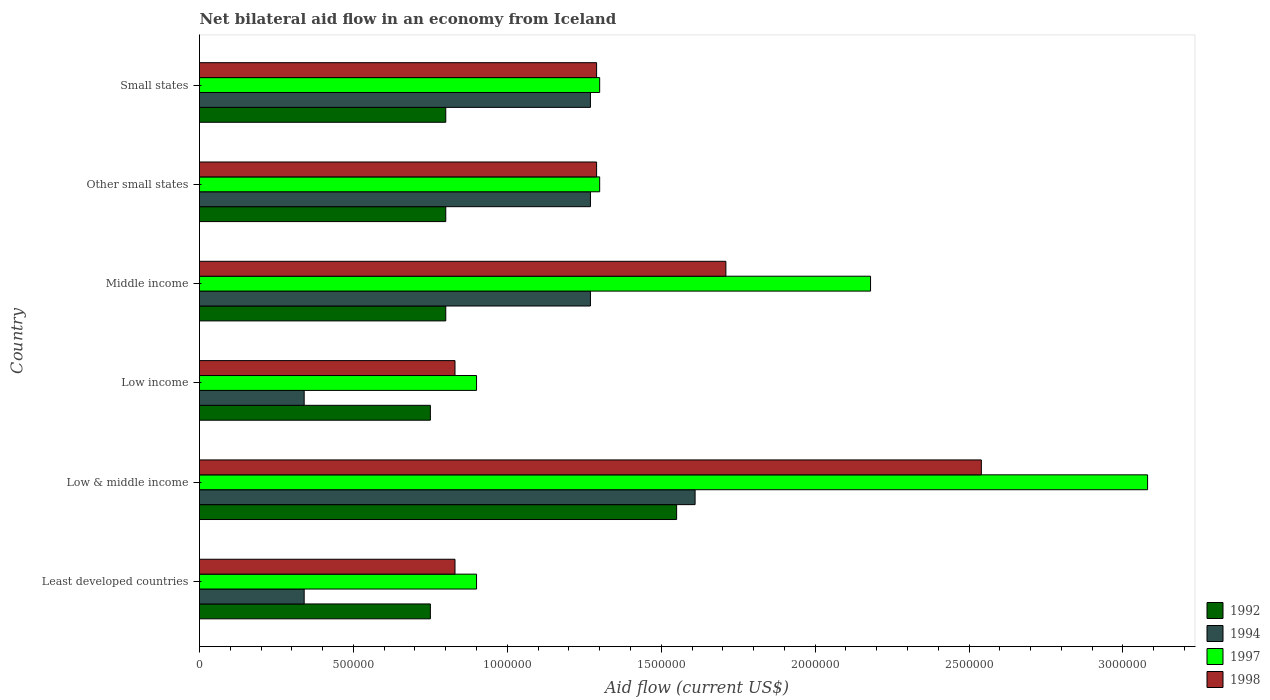Are the number of bars on each tick of the Y-axis equal?
Provide a succinct answer. Yes. Across all countries, what is the maximum net bilateral aid flow in 1992?
Provide a succinct answer. 1.55e+06. Across all countries, what is the minimum net bilateral aid flow in 1992?
Provide a short and direct response. 7.50e+05. In which country was the net bilateral aid flow in 1997 maximum?
Provide a short and direct response. Low & middle income. In which country was the net bilateral aid flow in 1997 minimum?
Keep it short and to the point. Least developed countries. What is the total net bilateral aid flow in 1994 in the graph?
Ensure brevity in your answer.  6.10e+06. What is the difference between the net bilateral aid flow in 1997 in Low & middle income and that in Middle income?
Provide a short and direct response. 9.00e+05. What is the difference between the net bilateral aid flow in 1997 in Middle income and the net bilateral aid flow in 1998 in Low income?
Offer a terse response. 1.35e+06. What is the average net bilateral aid flow in 1997 per country?
Ensure brevity in your answer.  1.61e+06. What is the difference between the net bilateral aid flow in 1997 and net bilateral aid flow in 1998 in Other small states?
Your answer should be compact. 10000. In how many countries, is the net bilateral aid flow in 1998 greater than 1200000 US$?
Your answer should be very brief. 4. What is the ratio of the net bilateral aid flow in 1992 in Low & middle income to that in Other small states?
Keep it short and to the point. 1.94. Is the net bilateral aid flow in 1998 in Low income less than that in Middle income?
Ensure brevity in your answer.  Yes. What is the difference between the highest and the second highest net bilateral aid flow in 1994?
Keep it short and to the point. 3.40e+05. What is the difference between the highest and the lowest net bilateral aid flow in 1992?
Your answer should be very brief. 8.00e+05. Is the sum of the net bilateral aid flow in 1994 in Low & middle income and Low income greater than the maximum net bilateral aid flow in 1992 across all countries?
Offer a very short reply. Yes. What does the 3rd bar from the top in Low & middle income represents?
Make the answer very short. 1994. What does the 4th bar from the bottom in Low income represents?
Provide a succinct answer. 1998. Is it the case that in every country, the sum of the net bilateral aid flow in 1994 and net bilateral aid flow in 1997 is greater than the net bilateral aid flow in 1998?
Your answer should be compact. Yes. How many bars are there?
Provide a short and direct response. 24. What is the difference between two consecutive major ticks on the X-axis?
Provide a short and direct response. 5.00e+05. Does the graph contain any zero values?
Your answer should be compact. No. How many legend labels are there?
Offer a very short reply. 4. How are the legend labels stacked?
Your answer should be very brief. Vertical. What is the title of the graph?
Your answer should be very brief. Net bilateral aid flow in an economy from Iceland. What is the label or title of the X-axis?
Make the answer very short. Aid flow (current US$). What is the Aid flow (current US$) in 1992 in Least developed countries?
Give a very brief answer. 7.50e+05. What is the Aid flow (current US$) of 1998 in Least developed countries?
Make the answer very short. 8.30e+05. What is the Aid flow (current US$) in 1992 in Low & middle income?
Offer a terse response. 1.55e+06. What is the Aid flow (current US$) of 1994 in Low & middle income?
Make the answer very short. 1.61e+06. What is the Aid flow (current US$) in 1997 in Low & middle income?
Your response must be concise. 3.08e+06. What is the Aid flow (current US$) of 1998 in Low & middle income?
Offer a very short reply. 2.54e+06. What is the Aid flow (current US$) of 1992 in Low income?
Keep it short and to the point. 7.50e+05. What is the Aid flow (current US$) of 1994 in Low income?
Make the answer very short. 3.40e+05. What is the Aid flow (current US$) in 1997 in Low income?
Offer a terse response. 9.00e+05. What is the Aid flow (current US$) in 1998 in Low income?
Keep it short and to the point. 8.30e+05. What is the Aid flow (current US$) of 1994 in Middle income?
Your answer should be very brief. 1.27e+06. What is the Aid flow (current US$) in 1997 in Middle income?
Make the answer very short. 2.18e+06. What is the Aid flow (current US$) of 1998 in Middle income?
Provide a short and direct response. 1.71e+06. What is the Aid flow (current US$) of 1992 in Other small states?
Provide a short and direct response. 8.00e+05. What is the Aid flow (current US$) in 1994 in Other small states?
Give a very brief answer. 1.27e+06. What is the Aid flow (current US$) in 1997 in Other small states?
Give a very brief answer. 1.30e+06. What is the Aid flow (current US$) of 1998 in Other small states?
Provide a succinct answer. 1.29e+06. What is the Aid flow (current US$) in 1994 in Small states?
Your answer should be very brief. 1.27e+06. What is the Aid flow (current US$) in 1997 in Small states?
Make the answer very short. 1.30e+06. What is the Aid flow (current US$) in 1998 in Small states?
Keep it short and to the point. 1.29e+06. Across all countries, what is the maximum Aid flow (current US$) of 1992?
Provide a short and direct response. 1.55e+06. Across all countries, what is the maximum Aid flow (current US$) of 1994?
Offer a terse response. 1.61e+06. Across all countries, what is the maximum Aid flow (current US$) in 1997?
Offer a very short reply. 3.08e+06. Across all countries, what is the maximum Aid flow (current US$) in 1998?
Your response must be concise. 2.54e+06. Across all countries, what is the minimum Aid flow (current US$) of 1992?
Offer a terse response. 7.50e+05. Across all countries, what is the minimum Aid flow (current US$) of 1994?
Your answer should be compact. 3.40e+05. Across all countries, what is the minimum Aid flow (current US$) in 1998?
Keep it short and to the point. 8.30e+05. What is the total Aid flow (current US$) in 1992 in the graph?
Keep it short and to the point. 5.45e+06. What is the total Aid flow (current US$) in 1994 in the graph?
Offer a very short reply. 6.10e+06. What is the total Aid flow (current US$) of 1997 in the graph?
Provide a short and direct response. 9.66e+06. What is the total Aid flow (current US$) in 1998 in the graph?
Your response must be concise. 8.49e+06. What is the difference between the Aid flow (current US$) of 1992 in Least developed countries and that in Low & middle income?
Your answer should be compact. -8.00e+05. What is the difference between the Aid flow (current US$) in 1994 in Least developed countries and that in Low & middle income?
Ensure brevity in your answer.  -1.27e+06. What is the difference between the Aid flow (current US$) in 1997 in Least developed countries and that in Low & middle income?
Your answer should be compact. -2.18e+06. What is the difference between the Aid flow (current US$) of 1998 in Least developed countries and that in Low & middle income?
Provide a short and direct response. -1.71e+06. What is the difference between the Aid flow (current US$) of 1992 in Least developed countries and that in Low income?
Give a very brief answer. 0. What is the difference between the Aid flow (current US$) in 1994 in Least developed countries and that in Low income?
Provide a short and direct response. 0. What is the difference between the Aid flow (current US$) of 1994 in Least developed countries and that in Middle income?
Offer a terse response. -9.30e+05. What is the difference between the Aid flow (current US$) in 1997 in Least developed countries and that in Middle income?
Offer a terse response. -1.28e+06. What is the difference between the Aid flow (current US$) of 1998 in Least developed countries and that in Middle income?
Your response must be concise. -8.80e+05. What is the difference between the Aid flow (current US$) in 1992 in Least developed countries and that in Other small states?
Provide a succinct answer. -5.00e+04. What is the difference between the Aid flow (current US$) of 1994 in Least developed countries and that in Other small states?
Your response must be concise. -9.30e+05. What is the difference between the Aid flow (current US$) of 1997 in Least developed countries and that in Other small states?
Give a very brief answer. -4.00e+05. What is the difference between the Aid flow (current US$) of 1998 in Least developed countries and that in Other small states?
Make the answer very short. -4.60e+05. What is the difference between the Aid flow (current US$) in 1992 in Least developed countries and that in Small states?
Your answer should be very brief. -5.00e+04. What is the difference between the Aid flow (current US$) of 1994 in Least developed countries and that in Small states?
Your response must be concise. -9.30e+05. What is the difference between the Aid flow (current US$) in 1997 in Least developed countries and that in Small states?
Provide a succinct answer. -4.00e+05. What is the difference between the Aid flow (current US$) in 1998 in Least developed countries and that in Small states?
Keep it short and to the point. -4.60e+05. What is the difference between the Aid flow (current US$) of 1992 in Low & middle income and that in Low income?
Ensure brevity in your answer.  8.00e+05. What is the difference between the Aid flow (current US$) of 1994 in Low & middle income and that in Low income?
Provide a succinct answer. 1.27e+06. What is the difference between the Aid flow (current US$) of 1997 in Low & middle income and that in Low income?
Provide a short and direct response. 2.18e+06. What is the difference between the Aid flow (current US$) of 1998 in Low & middle income and that in Low income?
Make the answer very short. 1.71e+06. What is the difference between the Aid flow (current US$) in 1992 in Low & middle income and that in Middle income?
Your response must be concise. 7.50e+05. What is the difference between the Aid flow (current US$) in 1998 in Low & middle income and that in Middle income?
Offer a terse response. 8.30e+05. What is the difference between the Aid flow (current US$) in 1992 in Low & middle income and that in Other small states?
Keep it short and to the point. 7.50e+05. What is the difference between the Aid flow (current US$) of 1994 in Low & middle income and that in Other small states?
Make the answer very short. 3.40e+05. What is the difference between the Aid flow (current US$) in 1997 in Low & middle income and that in Other small states?
Provide a short and direct response. 1.78e+06. What is the difference between the Aid flow (current US$) in 1998 in Low & middle income and that in Other small states?
Provide a succinct answer. 1.25e+06. What is the difference between the Aid flow (current US$) in 1992 in Low & middle income and that in Small states?
Offer a terse response. 7.50e+05. What is the difference between the Aid flow (current US$) in 1994 in Low & middle income and that in Small states?
Offer a very short reply. 3.40e+05. What is the difference between the Aid flow (current US$) in 1997 in Low & middle income and that in Small states?
Ensure brevity in your answer.  1.78e+06. What is the difference between the Aid flow (current US$) in 1998 in Low & middle income and that in Small states?
Ensure brevity in your answer.  1.25e+06. What is the difference between the Aid flow (current US$) of 1992 in Low income and that in Middle income?
Provide a short and direct response. -5.00e+04. What is the difference between the Aid flow (current US$) of 1994 in Low income and that in Middle income?
Your answer should be very brief. -9.30e+05. What is the difference between the Aid flow (current US$) of 1997 in Low income and that in Middle income?
Your answer should be very brief. -1.28e+06. What is the difference between the Aid flow (current US$) of 1998 in Low income and that in Middle income?
Make the answer very short. -8.80e+05. What is the difference between the Aid flow (current US$) in 1992 in Low income and that in Other small states?
Offer a very short reply. -5.00e+04. What is the difference between the Aid flow (current US$) in 1994 in Low income and that in Other small states?
Offer a terse response. -9.30e+05. What is the difference between the Aid flow (current US$) in 1997 in Low income and that in Other small states?
Your response must be concise. -4.00e+05. What is the difference between the Aid flow (current US$) in 1998 in Low income and that in Other small states?
Provide a short and direct response. -4.60e+05. What is the difference between the Aid flow (current US$) in 1992 in Low income and that in Small states?
Your answer should be compact. -5.00e+04. What is the difference between the Aid flow (current US$) of 1994 in Low income and that in Small states?
Offer a very short reply. -9.30e+05. What is the difference between the Aid flow (current US$) of 1997 in Low income and that in Small states?
Your answer should be very brief. -4.00e+05. What is the difference between the Aid flow (current US$) in 1998 in Low income and that in Small states?
Offer a very short reply. -4.60e+05. What is the difference between the Aid flow (current US$) in 1992 in Middle income and that in Other small states?
Make the answer very short. 0. What is the difference between the Aid flow (current US$) of 1994 in Middle income and that in Other small states?
Make the answer very short. 0. What is the difference between the Aid flow (current US$) of 1997 in Middle income and that in Other small states?
Offer a terse response. 8.80e+05. What is the difference between the Aid flow (current US$) of 1992 in Middle income and that in Small states?
Your response must be concise. 0. What is the difference between the Aid flow (current US$) of 1997 in Middle income and that in Small states?
Keep it short and to the point. 8.80e+05. What is the difference between the Aid flow (current US$) in 1998 in Middle income and that in Small states?
Offer a terse response. 4.20e+05. What is the difference between the Aid flow (current US$) in 1992 in Other small states and that in Small states?
Keep it short and to the point. 0. What is the difference between the Aid flow (current US$) of 1994 in Other small states and that in Small states?
Keep it short and to the point. 0. What is the difference between the Aid flow (current US$) in 1998 in Other small states and that in Small states?
Your answer should be compact. 0. What is the difference between the Aid flow (current US$) of 1992 in Least developed countries and the Aid flow (current US$) of 1994 in Low & middle income?
Make the answer very short. -8.60e+05. What is the difference between the Aid flow (current US$) in 1992 in Least developed countries and the Aid flow (current US$) in 1997 in Low & middle income?
Ensure brevity in your answer.  -2.33e+06. What is the difference between the Aid flow (current US$) in 1992 in Least developed countries and the Aid flow (current US$) in 1998 in Low & middle income?
Your answer should be compact. -1.79e+06. What is the difference between the Aid flow (current US$) in 1994 in Least developed countries and the Aid flow (current US$) in 1997 in Low & middle income?
Offer a very short reply. -2.74e+06. What is the difference between the Aid flow (current US$) of 1994 in Least developed countries and the Aid flow (current US$) of 1998 in Low & middle income?
Your answer should be very brief. -2.20e+06. What is the difference between the Aid flow (current US$) of 1997 in Least developed countries and the Aid flow (current US$) of 1998 in Low & middle income?
Keep it short and to the point. -1.64e+06. What is the difference between the Aid flow (current US$) of 1992 in Least developed countries and the Aid flow (current US$) of 1997 in Low income?
Your answer should be compact. -1.50e+05. What is the difference between the Aid flow (current US$) in 1994 in Least developed countries and the Aid flow (current US$) in 1997 in Low income?
Your answer should be very brief. -5.60e+05. What is the difference between the Aid flow (current US$) of 1994 in Least developed countries and the Aid flow (current US$) of 1998 in Low income?
Keep it short and to the point. -4.90e+05. What is the difference between the Aid flow (current US$) of 1997 in Least developed countries and the Aid flow (current US$) of 1998 in Low income?
Offer a very short reply. 7.00e+04. What is the difference between the Aid flow (current US$) of 1992 in Least developed countries and the Aid flow (current US$) of 1994 in Middle income?
Offer a very short reply. -5.20e+05. What is the difference between the Aid flow (current US$) in 1992 in Least developed countries and the Aid flow (current US$) in 1997 in Middle income?
Make the answer very short. -1.43e+06. What is the difference between the Aid flow (current US$) of 1992 in Least developed countries and the Aid flow (current US$) of 1998 in Middle income?
Your answer should be very brief. -9.60e+05. What is the difference between the Aid flow (current US$) of 1994 in Least developed countries and the Aid flow (current US$) of 1997 in Middle income?
Keep it short and to the point. -1.84e+06. What is the difference between the Aid flow (current US$) of 1994 in Least developed countries and the Aid flow (current US$) of 1998 in Middle income?
Provide a short and direct response. -1.37e+06. What is the difference between the Aid flow (current US$) of 1997 in Least developed countries and the Aid flow (current US$) of 1998 in Middle income?
Your answer should be very brief. -8.10e+05. What is the difference between the Aid flow (current US$) in 1992 in Least developed countries and the Aid flow (current US$) in 1994 in Other small states?
Provide a succinct answer. -5.20e+05. What is the difference between the Aid flow (current US$) of 1992 in Least developed countries and the Aid flow (current US$) of 1997 in Other small states?
Give a very brief answer. -5.50e+05. What is the difference between the Aid flow (current US$) of 1992 in Least developed countries and the Aid flow (current US$) of 1998 in Other small states?
Your answer should be compact. -5.40e+05. What is the difference between the Aid flow (current US$) of 1994 in Least developed countries and the Aid flow (current US$) of 1997 in Other small states?
Your answer should be compact. -9.60e+05. What is the difference between the Aid flow (current US$) in 1994 in Least developed countries and the Aid flow (current US$) in 1998 in Other small states?
Ensure brevity in your answer.  -9.50e+05. What is the difference between the Aid flow (current US$) in 1997 in Least developed countries and the Aid flow (current US$) in 1998 in Other small states?
Keep it short and to the point. -3.90e+05. What is the difference between the Aid flow (current US$) of 1992 in Least developed countries and the Aid flow (current US$) of 1994 in Small states?
Offer a very short reply. -5.20e+05. What is the difference between the Aid flow (current US$) of 1992 in Least developed countries and the Aid flow (current US$) of 1997 in Small states?
Offer a terse response. -5.50e+05. What is the difference between the Aid flow (current US$) of 1992 in Least developed countries and the Aid flow (current US$) of 1998 in Small states?
Your response must be concise. -5.40e+05. What is the difference between the Aid flow (current US$) of 1994 in Least developed countries and the Aid flow (current US$) of 1997 in Small states?
Offer a very short reply. -9.60e+05. What is the difference between the Aid flow (current US$) of 1994 in Least developed countries and the Aid flow (current US$) of 1998 in Small states?
Your response must be concise. -9.50e+05. What is the difference between the Aid flow (current US$) of 1997 in Least developed countries and the Aid flow (current US$) of 1998 in Small states?
Your answer should be very brief. -3.90e+05. What is the difference between the Aid flow (current US$) of 1992 in Low & middle income and the Aid flow (current US$) of 1994 in Low income?
Make the answer very short. 1.21e+06. What is the difference between the Aid flow (current US$) of 1992 in Low & middle income and the Aid flow (current US$) of 1997 in Low income?
Your response must be concise. 6.50e+05. What is the difference between the Aid flow (current US$) of 1992 in Low & middle income and the Aid flow (current US$) of 1998 in Low income?
Make the answer very short. 7.20e+05. What is the difference between the Aid flow (current US$) in 1994 in Low & middle income and the Aid flow (current US$) in 1997 in Low income?
Provide a succinct answer. 7.10e+05. What is the difference between the Aid flow (current US$) in 1994 in Low & middle income and the Aid flow (current US$) in 1998 in Low income?
Ensure brevity in your answer.  7.80e+05. What is the difference between the Aid flow (current US$) in 1997 in Low & middle income and the Aid flow (current US$) in 1998 in Low income?
Your answer should be very brief. 2.25e+06. What is the difference between the Aid flow (current US$) of 1992 in Low & middle income and the Aid flow (current US$) of 1994 in Middle income?
Offer a terse response. 2.80e+05. What is the difference between the Aid flow (current US$) of 1992 in Low & middle income and the Aid flow (current US$) of 1997 in Middle income?
Keep it short and to the point. -6.30e+05. What is the difference between the Aid flow (current US$) in 1992 in Low & middle income and the Aid flow (current US$) in 1998 in Middle income?
Offer a very short reply. -1.60e+05. What is the difference between the Aid flow (current US$) of 1994 in Low & middle income and the Aid flow (current US$) of 1997 in Middle income?
Your answer should be compact. -5.70e+05. What is the difference between the Aid flow (current US$) in 1997 in Low & middle income and the Aid flow (current US$) in 1998 in Middle income?
Your answer should be very brief. 1.37e+06. What is the difference between the Aid flow (current US$) in 1992 in Low & middle income and the Aid flow (current US$) in 1994 in Other small states?
Offer a very short reply. 2.80e+05. What is the difference between the Aid flow (current US$) in 1992 in Low & middle income and the Aid flow (current US$) in 1997 in Other small states?
Give a very brief answer. 2.50e+05. What is the difference between the Aid flow (current US$) of 1992 in Low & middle income and the Aid flow (current US$) of 1998 in Other small states?
Your answer should be very brief. 2.60e+05. What is the difference between the Aid flow (current US$) of 1994 in Low & middle income and the Aid flow (current US$) of 1997 in Other small states?
Ensure brevity in your answer.  3.10e+05. What is the difference between the Aid flow (current US$) of 1994 in Low & middle income and the Aid flow (current US$) of 1998 in Other small states?
Provide a succinct answer. 3.20e+05. What is the difference between the Aid flow (current US$) of 1997 in Low & middle income and the Aid flow (current US$) of 1998 in Other small states?
Your answer should be compact. 1.79e+06. What is the difference between the Aid flow (current US$) of 1997 in Low & middle income and the Aid flow (current US$) of 1998 in Small states?
Give a very brief answer. 1.79e+06. What is the difference between the Aid flow (current US$) of 1992 in Low income and the Aid flow (current US$) of 1994 in Middle income?
Your answer should be very brief. -5.20e+05. What is the difference between the Aid flow (current US$) in 1992 in Low income and the Aid flow (current US$) in 1997 in Middle income?
Give a very brief answer. -1.43e+06. What is the difference between the Aid flow (current US$) in 1992 in Low income and the Aid flow (current US$) in 1998 in Middle income?
Give a very brief answer. -9.60e+05. What is the difference between the Aid flow (current US$) of 1994 in Low income and the Aid flow (current US$) of 1997 in Middle income?
Ensure brevity in your answer.  -1.84e+06. What is the difference between the Aid flow (current US$) of 1994 in Low income and the Aid flow (current US$) of 1998 in Middle income?
Your response must be concise. -1.37e+06. What is the difference between the Aid flow (current US$) in 1997 in Low income and the Aid flow (current US$) in 1998 in Middle income?
Offer a very short reply. -8.10e+05. What is the difference between the Aid flow (current US$) in 1992 in Low income and the Aid flow (current US$) in 1994 in Other small states?
Provide a short and direct response. -5.20e+05. What is the difference between the Aid flow (current US$) of 1992 in Low income and the Aid flow (current US$) of 1997 in Other small states?
Ensure brevity in your answer.  -5.50e+05. What is the difference between the Aid flow (current US$) in 1992 in Low income and the Aid flow (current US$) in 1998 in Other small states?
Provide a succinct answer. -5.40e+05. What is the difference between the Aid flow (current US$) of 1994 in Low income and the Aid flow (current US$) of 1997 in Other small states?
Give a very brief answer. -9.60e+05. What is the difference between the Aid flow (current US$) in 1994 in Low income and the Aid flow (current US$) in 1998 in Other small states?
Offer a very short reply. -9.50e+05. What is the difference between the Aid flow (current US$) in 1997 in Low income and the Aid flow (current US$) in 1998 in Other small states?
Provide a short and direct response. -3.90e+05. What is the difference between the Aid flow (current US$) in 1992 in Low income and the Aid flow (current US$) in 1994 in Small states?
Provide a short and direct response. -5.20e+05. What is the difference between the Aid flow (current US$) of 1992 in Low income and the Aid flow (current US$) of 1997 in Small states?
Keep it short and to the point. -5.50e+05. What is the difference between the Aid flow (current US$) in 1992 in Low income and the Aid flow (current US$) in 1998 in Small states?
Offer a very short reply. -5.40e+05. What is the difference between the Aid flow (current US$) in 1994 in Low income and the Aid flow (current US$) in 1997 in Small states?
Provide a succinct answer. -9.60e+05. What is the difference between the Aid flow (current US$) in 1994 in Low income and the Aid flow (current US$) in 1998 in Small states?
Provide a short and direct response. -9.50e+05. What is the difference between the Aid flow (current US$) of 1997 in Low income and the Aid flow (current US$) of 1998 in Small states?
Provide a succinct answer. -3.90e+05. What is the difference between the Aid flow (current US$) in 1992 in Middle income and the Aid flow (current US$) in 1994 in Other small states?
Your answer should be compact. -4.70e+05. What is the difference between the Aid flow (current US$) of 1992 in Middle income and the Aid flow (current US$) of 1997 in Other small states?
Your answer should be compact. -5.00e+05. What is the difference between the Aid flow (current US$) in 1992 in Middle income and the Aid flow (current US$) in 1998 in Other small states?
Your answer should be compact. -4.90e+05. What is the difference between the Aid flow (current US$) of 1997 in Middle income and the Aid flow (current US$) of 1998 in Other small states?
Ensure brevity in your answer.  8.90e+05. What is the difference between the Aid flow (current US$) in 1992 in Middle income and the Aid flow (current US$) in 1994 in Small states?
Keep it short and to the point. -4.70e+05. What is the difference between the Aid flow (current US$) of 1992 in Middle income and the Aid flow (current US$) of 1997 in Small states?
Keep it short and to the point. -5.00e+05. What is the difference between the Aid flow (current US$) of 1992 in Middle income and the Aid flow (current US$) of 1998 in Small states?
Keep it short and to the point. -4.90e+05. What is the difference between the Aid flow (current US$) of 1994 in Middle income and the Aid flow (current US$) of 1997 in Small states?
Your answer should be compact. -3.00e+04. What is the difference between the Aid flow (current US$) in 1994 in Middle income and the Aid flow (current US$) in 1998 in Small states?
Offer a very short reply. -2.00e+04. What is the difference between the Aid flow (current US$) of 1997 in Middle income and the Aid flow (current US$) of 1998 in Small states?
Your answer should be very brief. 8.90e+05. What is the difference between the Aid flow (current US$) of 1992 in Other small states and the Aid flow (current US$) of 1994 in Small states?
Offer a very short reply. -4.70e+05. What is the difference between the Aid flow (current US$) in 1992 in Other small states and the Aid flow (current US$) in 1997 in Small states?
Ensure brevity in your answer.  -5.00e+05. What is the difference between the Aid flow (current US$) of 1992 in Other small states and the Aid flow (current US$) of 1998 in Small states?
Keep it short and to the point. -4.90e+05. What is the difference between the Aid flow (current US$) in 1994 in Other small states and the Aid flow (current US$) in 1997 in Small states?
Offer a terse response. -3.00e+04. What is the average Aid flow (current US$) in 1992 per country?
Your answer should be very brief. 9.08e+05. What is the average Aid flow (current US$) of 1994 per country?
Your response must be concise. 1.02e+06. What is the average Aid flow (current US$) in 1997 per country?
Give a very brief answer. 1.61e+06. What is the average Aid flow (current US$) of 1998 per country?
Make the answer very short. 1.42e+06. What is the difference between the Aid flow (current US$) in 1992 and Aid flow (current US$) in 1998 in Least developed countries?
Ensure brevity in your answer.  -8.00e+04. What is the difference between the Aid flow (current US$) of 1994 and Aid flow (current US$) of 1997 in Least developed countries?
Give a very brief answer. -5.60e+05. What is the difference between the Aid flow (current US$) of 1994 and Aid flow (current US$) of 1998 in Least developed countries?
Your answer should be compact. -4.90e+05. What is the difference between the Aid flow (current US$) of 1992 and Aid flow (current US$) of 1994 in Low & middle income?
Keep it short and to the point. -6.00e+04. What is the difference between the Aid flow (current US$) in 1992 and Aid flow (current US$) in 1997 in Low & middle income?
Your answer should be compact. -1.53e+06. What is the difference between the Aid flow (current US$) in 1992 and Aid flow (current US$) in 1998 in Low & middle income?
Keep it short and to the point. -9.90e+05. What is the difference between the Aid flow (current US$) of 1994 and Aid flow (current US$) of 1997 in Low & middle income?
Provide a short and direct response. -1.47e+06. What is the difference between the Aid flow (current US$) in 1994 and Aid flow (current US$) in 1998 in Low & middle income?
Offer a terse response. -9.30e+05. What is the difference between the Aid flow (current US$) of 1997 and Aid flow (current US$) of 1998 in Low & middle income?
Provide a short and direct response. 5.40e+05. What is the difference between the Aid flow (current US$) of 1992 and Aid flow (current US$) of 1994 in Low income?
Provide a short and direct response. 4.10e+05. What is the difference between the Aid flow (current US$) in 1992 and Aid flow (current US$) in 1998 in Low income?
Provide a short and direct response. -8.00e+04. What is the difference between the Aid flow (current US$) of 1994 and Aid flow (current US$) of 1997 in Low income?
Keep it short and to the point. -5.60e+05. What is the difference between the Aid flow (current US$) of 1994 and Aid flow (current US$) of 1998 in Low income?
Make the answer very short. -4.90e+05. What is the difference between the Aid flow (current US$) in 1997 and Aid flow (current US$) in 1998 in Low income?
Make the answer very short. 7.00e+04. What is the difference between the Aid flow (current US$) of 1992 and Aid flow (current US$) of 1994 in Middle income?
Your response must be concise. -4.70e+05. What is the difference between the Aid flow (current US$) in 1992 and Aid flow (current US$) in 1997 in Middle income?
Provide a short and direct response. -1.38e+06. What is the difference between the Aid flow (current US$) of 1992 and Aid flow (current US$) of 1998 in Middle income?
Your answer should be very brief. -9.10e+05. What is the difference between the Aid flow (current US$) in 1994 and Aid flow (current US$) in 1997 in Middle income?
Offer a terse response. -9.10e+05. What is the difference between the Aid flow (current US$) of 1994 and Aid flow (current US$) of 1998 in Middle income?
Provide a succinct answer. -4.40e+05. What is the difference between the Aid flow (current US$) of 1997 and Aid flow (current US$) of 1998 in Middle income?
Offer a very short reply. 4.70e+05. What is the difference between the Aid flow (current US$) in 1992 and Aid flow (current US$) in 1994 in Other small states?
Provide a succinct answer. -4.70e+05. What is the difference between the Aid flow (current US$) of 1992 and Aid flow (current US$) of 1997 in Other small states?
Ensure brevity in your answer.  -5.00e+05. What is the difference between the Aid flow (current US$) in 1992 and Aid flow (current US$) in 1998 in Other small states?
Provide a short and direct response. -4.90e+05. What is the difference between the Aid flow (current US$) of 1994 and Aid flow (current US$) of 1997 in Other small states?
Make the answer very short. -3.00e+04. What is the difference between the Aid flow (current US$) in 1992 and Aid flow (current US$) in 1994 in Small states?
Provide a short and direct response. -4.70e+05. What is the difference between the Aid flow (current US$) of 1992 and Aid flow (current US$) of 1997 in Small states?
Offer a very short reply. -5.00e+05. What is the difference between the Aid flow (current US$) in 1992 and Aid flow (current US$) in 1998 in Small states?
Ensure brevity in your answer.  -4.90e+05. What is the ratio of the Aid flow (current US$) in 1992 in Least developed countries to that in Low & middle income?
Your response must be concise. 0.48. What is the ratio of the Aid flow (current US$) in 1994 in Least developed countries to that in Low & middle income?
Ensure brevity in your answer.  0.21. What is the ratio of the Aid flow (current US$) of 1997 in Least developed countries to that in Low & middle income?
Give a very brief answer. 0.29. What is the ratio of the Aid flow (current US$) in 1998 in Least developed countries to that in Low & middle income?
Offer a terse response. 0.33. What is the ratio of the Aid flow (current US$) of 1992 in Least developed countries to that in Low income?
Provide a succinct answer. 1. What is the ratio of the Aid flow (current US$) of 1998 in Least developed countries to that in Low income?
Offer a terse response. 1. What is the ratio of the Aid flow (current US$) of 1994 in Least developed countries to that in Middle income?
Your answer should be very brief. 0.27. What is the ratio of the Aid flow (current US$) in 1997 in Least developed countries to that in Middle income?
Offer a terse response. 0.41. What is the ratio of the Aid flow (current US$) of 1998 in Least developed countries to that in Middle income?
Make the answer very short. 0.49. What is the ratio of the Aid flow (current US$) of 1994 in Least developed countries to that in Other small states?
Your answer should be very brief. 0.27. What is the ratio of the Aid flow (current US$) in 1997 in Least developed countries to that in Other small states?
Keep it short and to the point. 0.69. What is the ratio of the Aid flow (current US$) of 1998 in Least developed countries to that in Other small states?
Give a very brief answer. 0.64. What is the ratio of the Aid flow (current US$) in 1992 in Least developed countries to that in Small states?
Offer a terse response. 0.94. What is the ratio of the Aid flow (current US$) in 1994 in Least developed countries to that in Small states?
Ensure brevity in your answer.  0.27. What is the ratio of the Aid flow (current US$) of 1997 in Least developed countries to that in Small states?
Your answer should be very brief. 0.69. What is the ratio of the Aid flow (current US$) of 1998 in Least developed countries to that in Small states?
Offer a very short reply. 0.64. What is the ratio of the Aid flow (current US$) in 1992 in Low & middle income to that in Low income?
Your answer should be very brief. 2.07. What is the ratio of the Aid flow (current US$) of 1994 in Low & middle income to that in Low income?
Provide a succinct answer. 4.74. What is the ratio of the Aid flow (current US$) in 1997 in Low & middle income to that in Low income?
Give a very brief answer. 3.42. What is the ratio of the Aid flow (current US$) in 1998 in Low & middle income to that in Low income?
Your answer should be compact. 3.06. What is the ratio of the Aid flow (current US$) in 1992 in Low & middle income to that in Middle income?
Your answer should be compact. 1.94. What is the ratio of the Aid flow (current US$) of 1994 in Low & middle income to that in Middle income?
Offer a terse response. 1.27. What is the ratio of the Aid flow (current US$) in 1997 in Low & middle income to that in Middle income?
Ensure brevity in your answer.  1.41. What is the ratio of the Aid flow (current US$) in 1998 in Low & middle income to that in Middle income?
Provide a short and direct response. 1.49. What is the ratio of the Aid flow (current US$) in 1992 in Low & middle income to that in Other small states?
Your answer should be very brief. 1.94. What is the ratio of the Aid flow (current US$) of 1994 in Low & middle income to that in Other small states?
Your answer should be compact. 1.27. What is the ratio of the Aid flow (current US$) in 1997 in Low & middle income to that in Other small states?
Your answer should be very brief. 2.37. What is the ratio of the Aid flow (current US$) of 1998 in Low & middle income to that in Other small states?
Your response must be concise. 1.97. What is the ratio of the Aid flow (current US$) in 1992 in Low & middle income to that in Small states?
Make the answer very short. 1.94. What is the ratio of the Aid flow (current US$) in 1994 in Low & middle income to that in Small states?
Offer a terse response. 1.27. What is the ratio of the Aid flow (current US$) in 1997 in Low & middle income to that in Small states?
Provide a short and direct response. 2.37. What is the ratio of the Aid flow (current US$) in 1998 in Low & middle income to that in Small states?
Your answer should be compact. 1.97. What is the ratio of the Aid flow (current US$) of 1994 in Low income to that in Middle income?
Ensure brevity in your answer.  0.27. What is the ratio of the Aid flow (current US$) in 1997 in Low income to that in Middle income?
Provide a short and direct response. 0.41. What is the ratio of the Aid flow (current US$) in 1998 in Low income to that in Middle income?
Provide a short and direct response. 0.49. What is the ratio of the Aid flow (current US$) in 1992 in Low income to that in Other small states?
Keep it short and to the point. 0.94. What is the ratio of the Aid flow (current US$) of 1994 in Low income to that in Other small states?
Offer a terse response. 0.27. What is the ratio of the Aid flow (current US$) in 1997 in Low income to that in Other small states?
Offer a terse response. 0.69. What is the ratio of the Aid flow (current US$) in 1998 in Low income to that in Other small states?
Your answer should be very brief. 0.64. What is the ratio of the Aid flow (current US$) of 1994 in Low income to that in Small states?
Your response must be concise. 0.27. What is the ratio of the Aid flow (current US$) in 1997 in Low income to that in Small states?
Your response must be concise. 0.69. What is the ratio of the Aid flow (current US$) of 1998 in Low income to that in Small states?
Your answer should be compact. 0.64. What is the ratio of the Aid flow (current US$) of 1994 in Middle income to that in Other small states?
Your answer should be compact. 1. What is the ratio of the Aid flow (current US$) of 1997 in Middle income to that in Other small states?
Your answer should be compact. 1.68. What is the ratio of the Aid flow (current US$) in 1998 in Middle income to that in Other small states?
Your answer should be very brief. 1.33. What is the ratio of the Aid flow (current US$) of 1997 in Middle income to that in Small states?
Your response must be concise. 1.68. What is the ratio of the Aid flow (current US$) of 1998 in Middle income to that in Small states?
Offer a terse response. 1.33. What is the ratio of the Aid flow (current US$) of 1992 in Other small states to that in Small states?
Provide a succinct answer. 1. What is the ratio of the Aid flow (current US$) in 1994 in Other small states to that in Small states?
Your response must be concise. 1. What is the ratio of the Aid flow (current US$) of 1997 in Other small states to that in Small states?
Ensure brevity in your answer.  1. What is the difference between the highest and the second highest Aid flow (current US$) of 1992?
Your answer should be compact. 7.50e+05. What is the difference between the highest and the second highest Aid flow (current US$) of 1994?
Keep it short and to the point. 3.40e+05. What is the difference between the highest and the second highest Aid flow (current US$) in 1998?
Offer a terse response. 8.30e+05. What is the difference between the highest and the lowest Aid flow (current US$) of 1994?
Ensure brevity in your answer.  1.27e+06. What is the difference between the highest and the lowest Aid flow (current US$) in 1997?
Give a very brief answer. 2.18e+06. What is the difference between the highest and the lowest Aid flow (current US$) of 1998?
Offer a very short reply. 1.71e+06. 